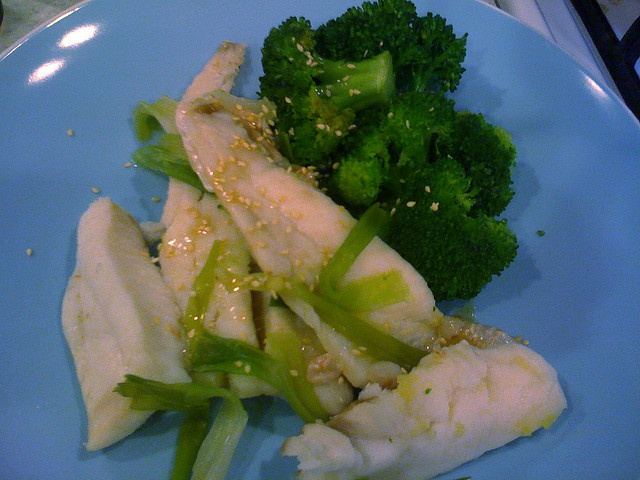Describe the objects in this image and their specific colors. I can see a broccoli in black, darkgreen, and blue tones in this image. 